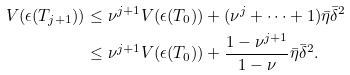Convert formula to latex. <formula><loc_0><loc_0><loc_500><loc_500>V ( \epsilon ( T _ { j + 1 } ) ) & \leq \nu ^ { j + 1 } V ( \epsilon ( T _ { 0 } ) ) + ( \nu ^ { j } + \cdots + 1 ) \bar { \eta } \bar { \delta } ^ { 2 } \\ & \leq \nu ^ { j + 1 } V ( \epsilon ( T _ { 0 } ) ) + \frac { 1 - \nu ^ { j + 1 } } { 1 - \nu } \bar { \eta } \bar { \delta } ^ { 2 } .</formula> 